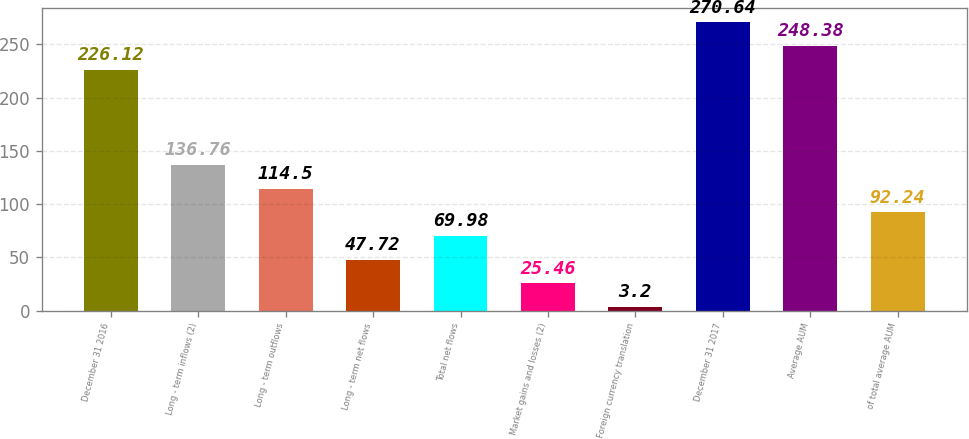<chart> <loc_0><loc_0><loc_500><loc_500><bar_chart><fcel>December 31 2016<fcel>Long - term inflows (2)<fcel>Long - term outflows<fcel>Long - term net flows<fcel>Total net flows<fcel>Market gains and losses (2)<fcel>Foreign currency translation<fcel>December 31 2017<fcel>Average AUM<fcel>of total average AUM<nl><fcel>226.12<fcel>136.76<fcel>114.5<fcel>47.72<fcel>69.98<fcel>25.46<fcel>3.2<fcel>270.64<fcel>248.38<fcel>92.24<nl></chart> 